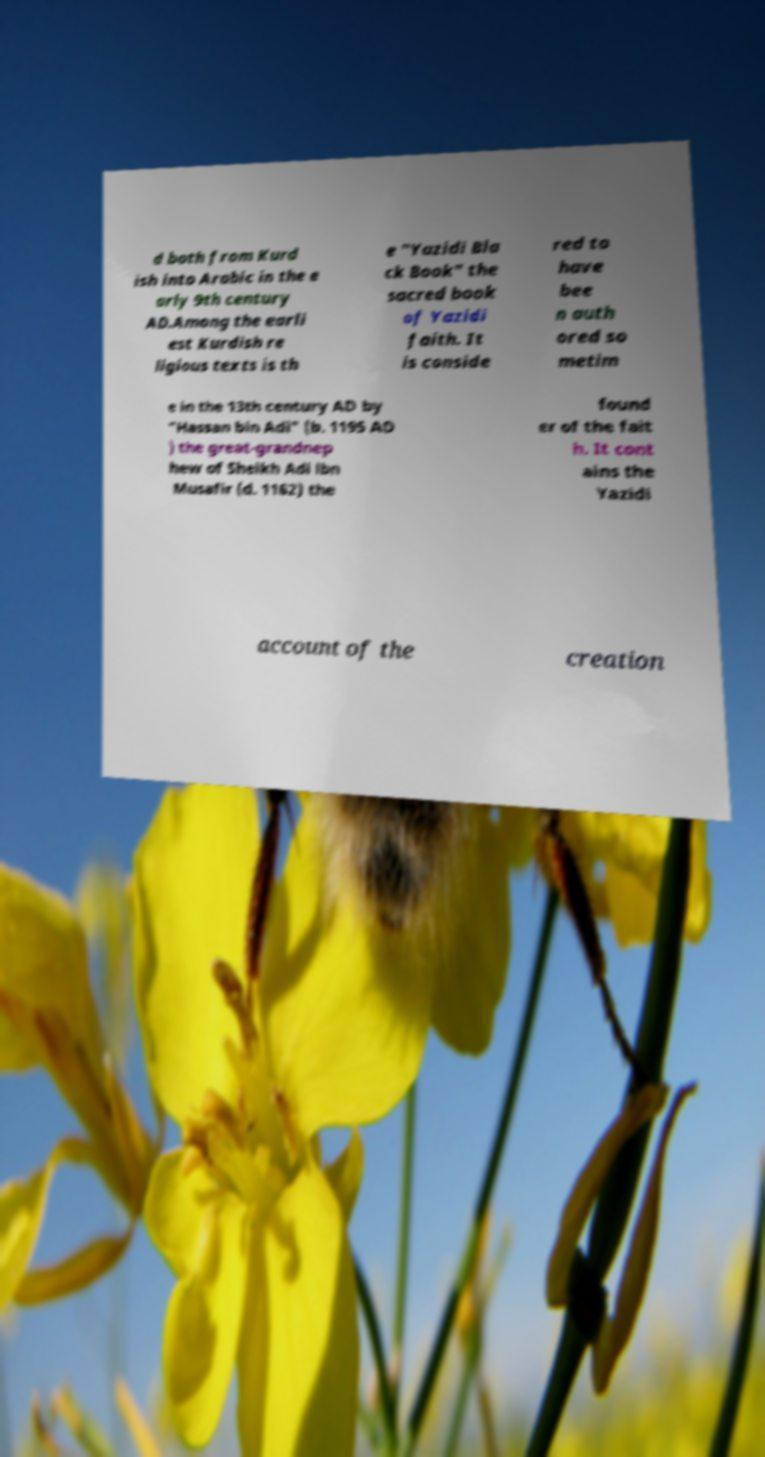Can you accurately transcribe the text from the provided image for me? d both from Kurd ish into Arabic in the e arly 9th century AD.Among the earli est Kurdish re ligious texts is th e "Yazidi Bla ck Book" the sacred book of Yazidi faith. It is conside red to have bee n auth ored so metim e in the 13th century AD by "Hassan bin Adi" (b. 1195 AD ) the great-grandnep hew of Sheikh Adi ibn Musafir (d. 1162) the found er of the fait h. It cont ains the Yazidi account of the creation 